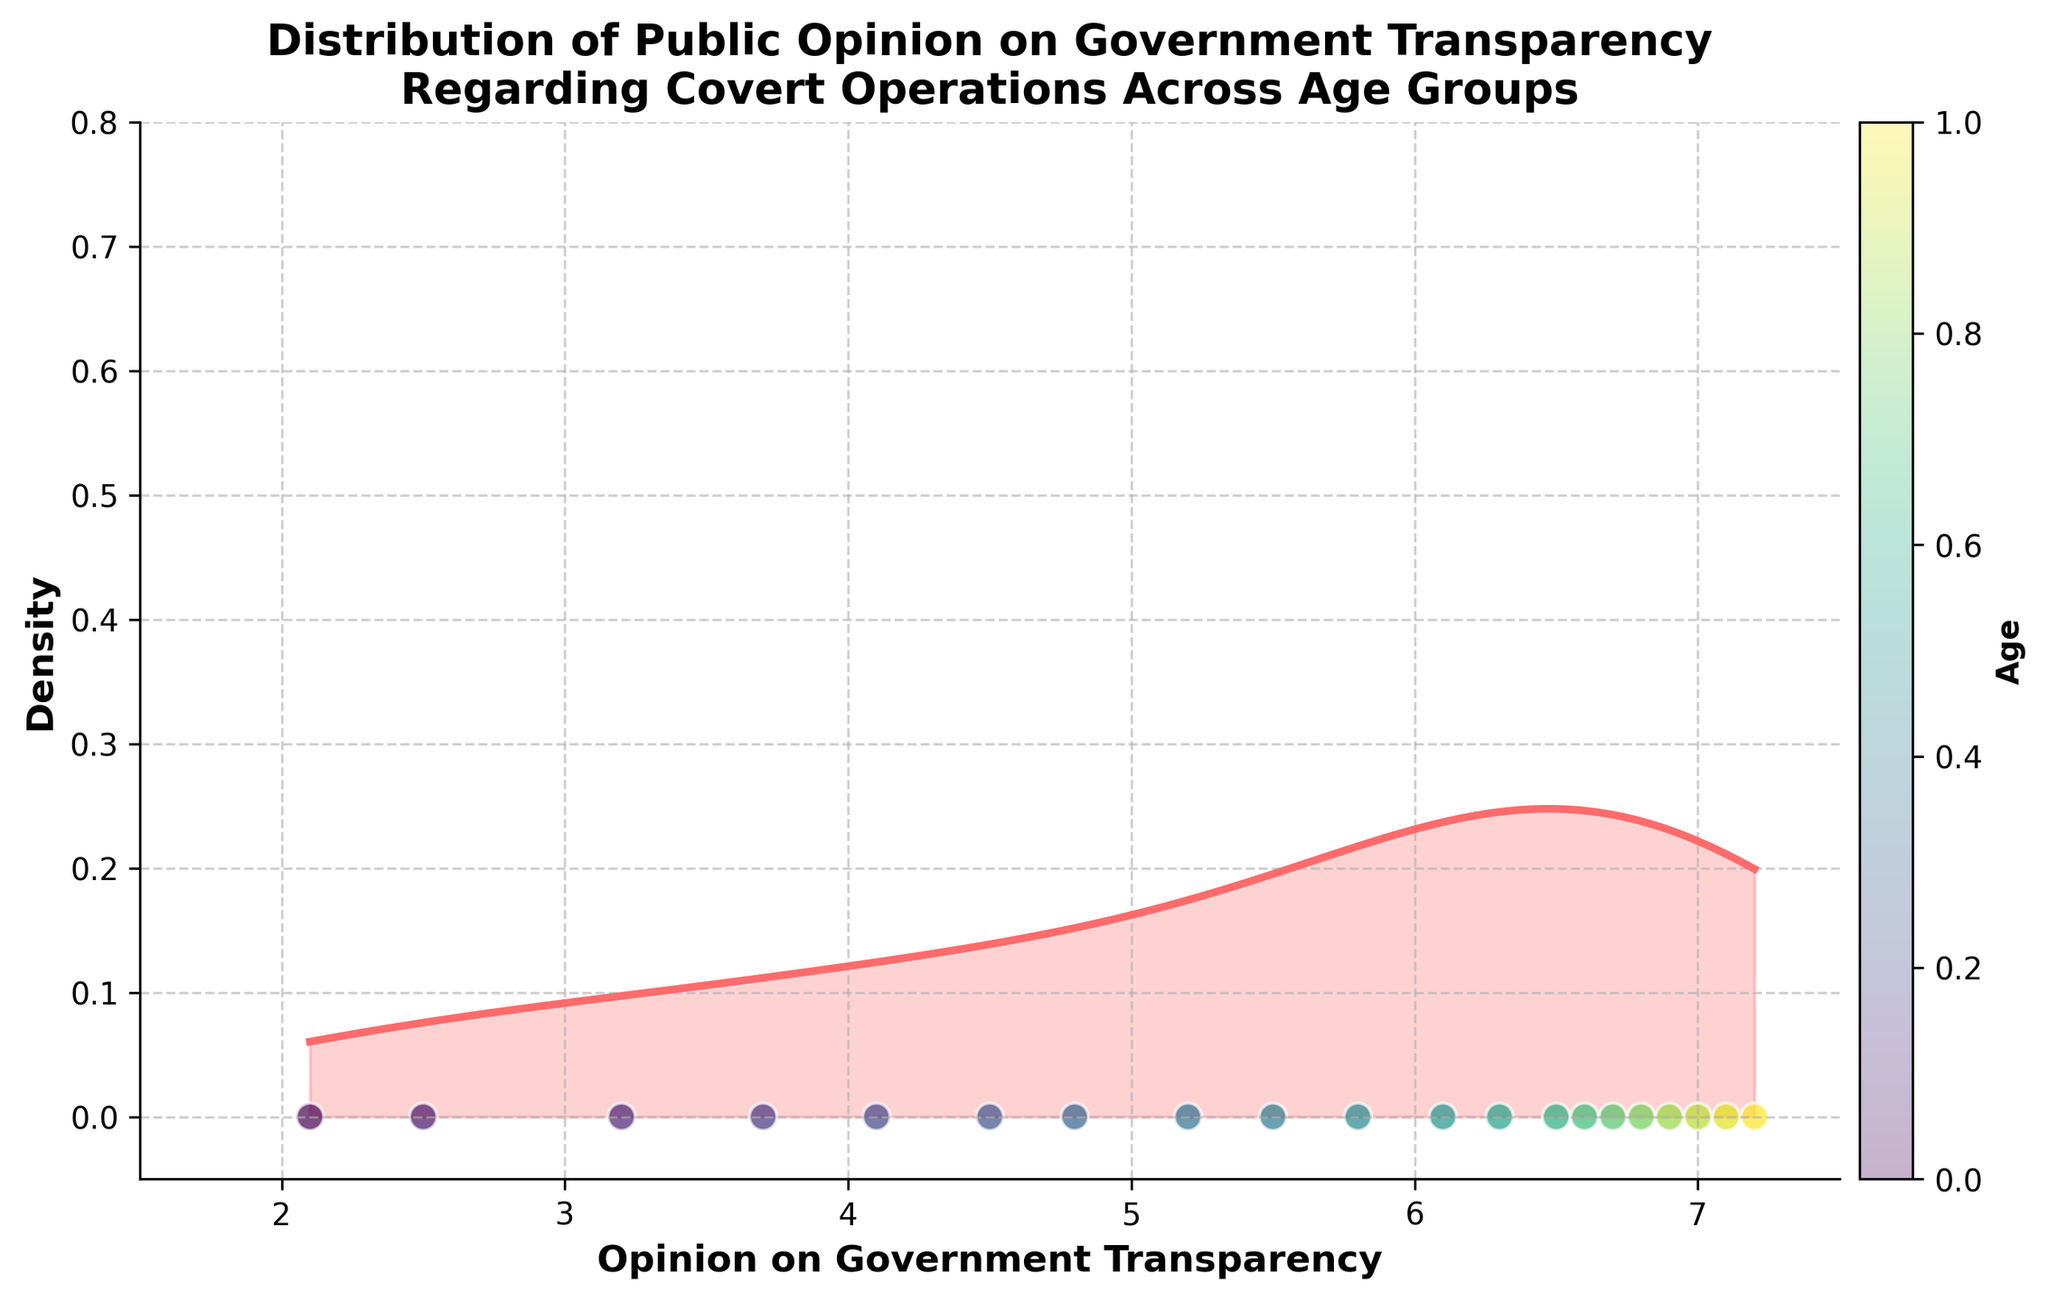What is the title of the plot? The title is located at the top of the plot and summarizes the main topic being visualized. It reads: "Distribution of Public Opinion on Government Transparency Regarding Covert Operations Across Age Groups".
Answer: Distribution of Public Opinion on Government Transparency Regarding Covert Operations Across Age Groups What are the labels of the x-axis and y-axis? The x-axis label, located below the horizontal axis, is "Opinion on Government Transparency", and the y-axis label, found next to the vertical axis, is "Density".
Answer: Opinion on Government Transparency, Density What does the color of the scatter points represent? The color of the scatter points, as indicated by the accompanying colorbar on the right side of the plot, represents different age groups. Darker colors indicate younger age groups, and lighter colors indicate older age groups.
Answer: Age groups How would you describe the overall shape of the density plot? The density plot shows a smooth curve with a peak and a gradual decline, indicating the distribution of opinions on government transparency. The curve rises to a peak and then falls off.
Answer: Smooth curve with a peak What is the range of opinions on government transparency according to the x-axis? The x-axis shows the range of opinions, which spans from approximately 1.5 to 7.5.
Answer: 1.5 to 7.5 How many distinct age groups are represented in the scatter plot? The colorbar indicates the age groups with a colormap that ranges from young to old. Since the data consists of ages ranging from 18 to 93, there are numerous distinct age groups, specifically 20 different age points.
Answer: 20 At which opinion value does the density peak occur? By observing the highest point of the density curve on the x-axis, the peak of the density occurs around a value of 6.5.
Answer: Around 6.5 How is the distribution of opinions for individuals aged 85 and older represented in the plot? Individuals aged 85 and older are represented by the lightest colors in the scatter plot. The scatter points with these colors are concentrated around the higher end of the opinion values, typically from 6.5 to 7.2.
Answer: Around 6.5 to 7.2 Which age group shows the widest range of opinion values? Examining the scatter points and their colors, younger individuals, specifically those around age 18-29, display a wider spread of opinion values, ranging from as low as 2.1 to up to 5.2.
Answer: Younger individuals (18-29) Is there any age group whose opinion values are primarily limited to a narrow range? Yes, older age groups, especially those around age 77 to 93, have opinion values concentrated around the higher range, specifically from 6.6 to 7.2, indicating a narrower range.
Answer: Older age groups (77-93) 